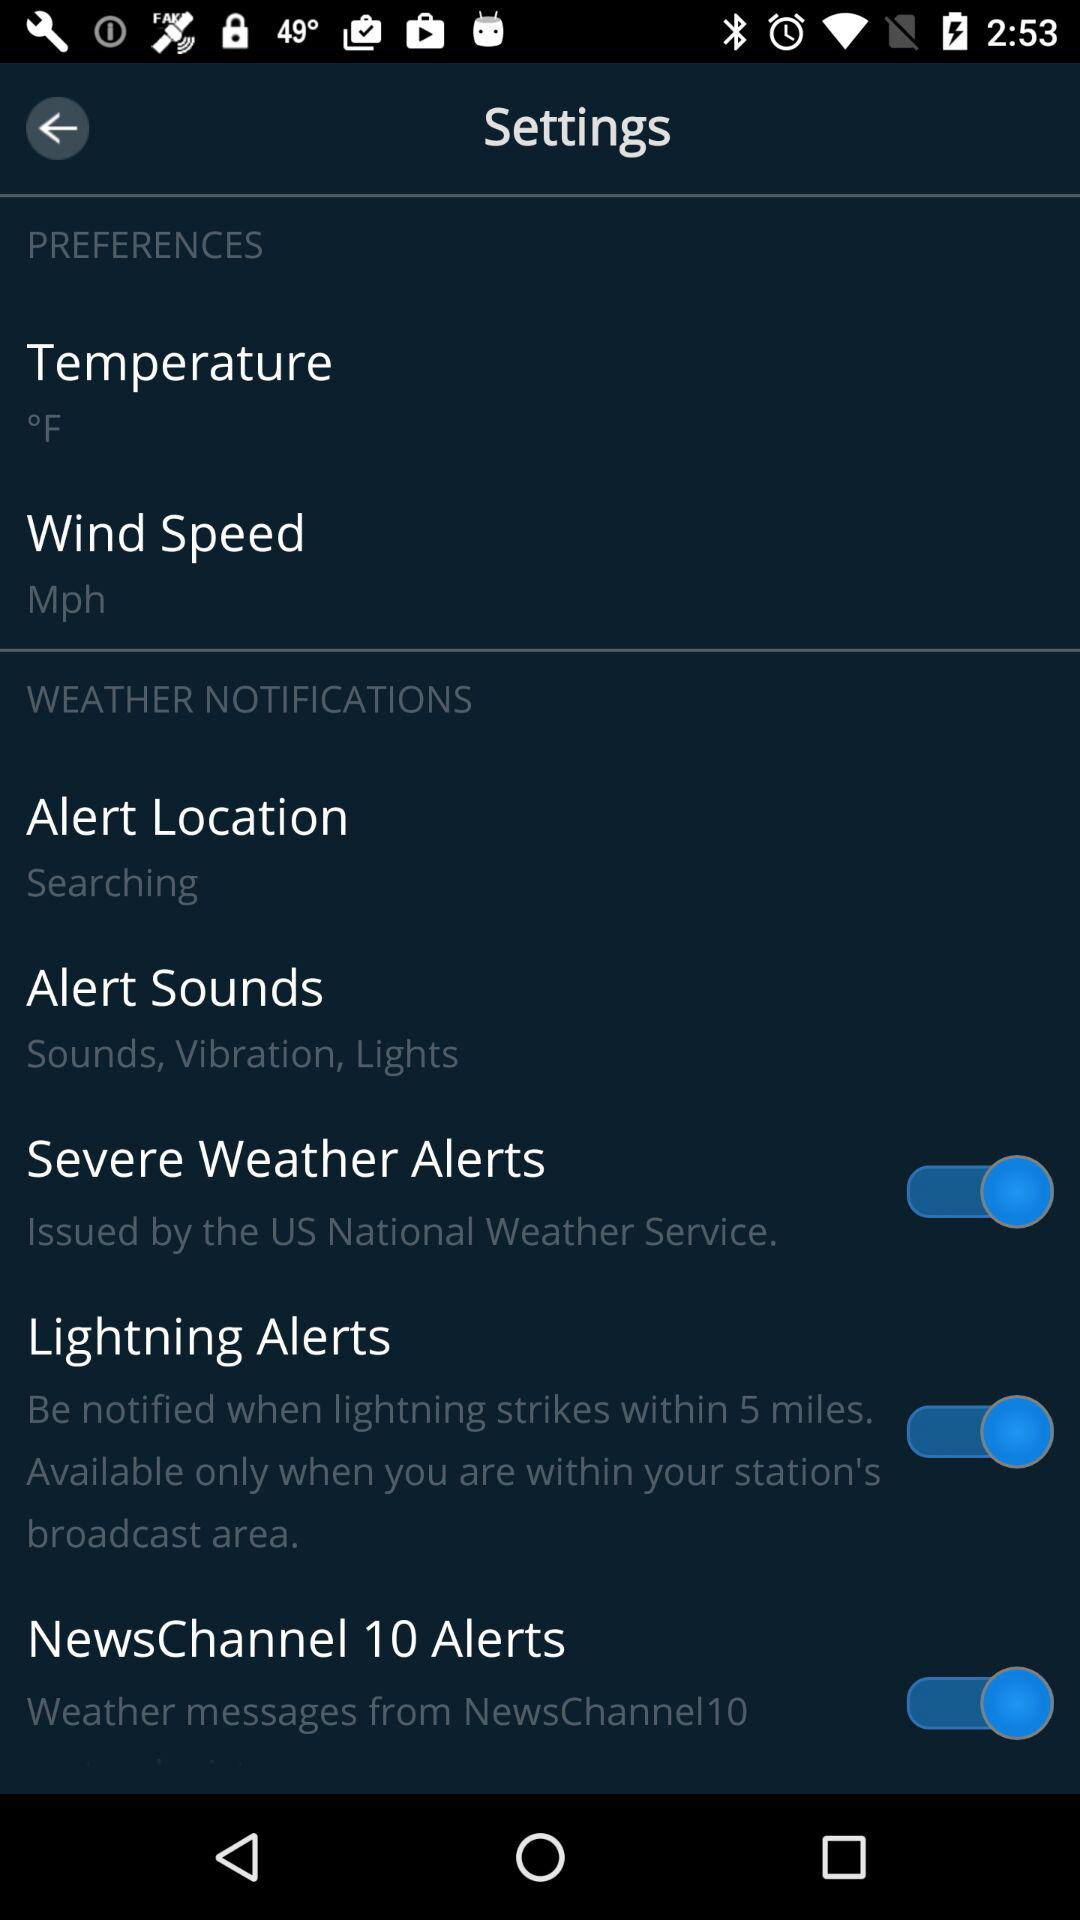What is the mentioned unit of the wind speed? The mentioned unit of the wind speed is mph. 